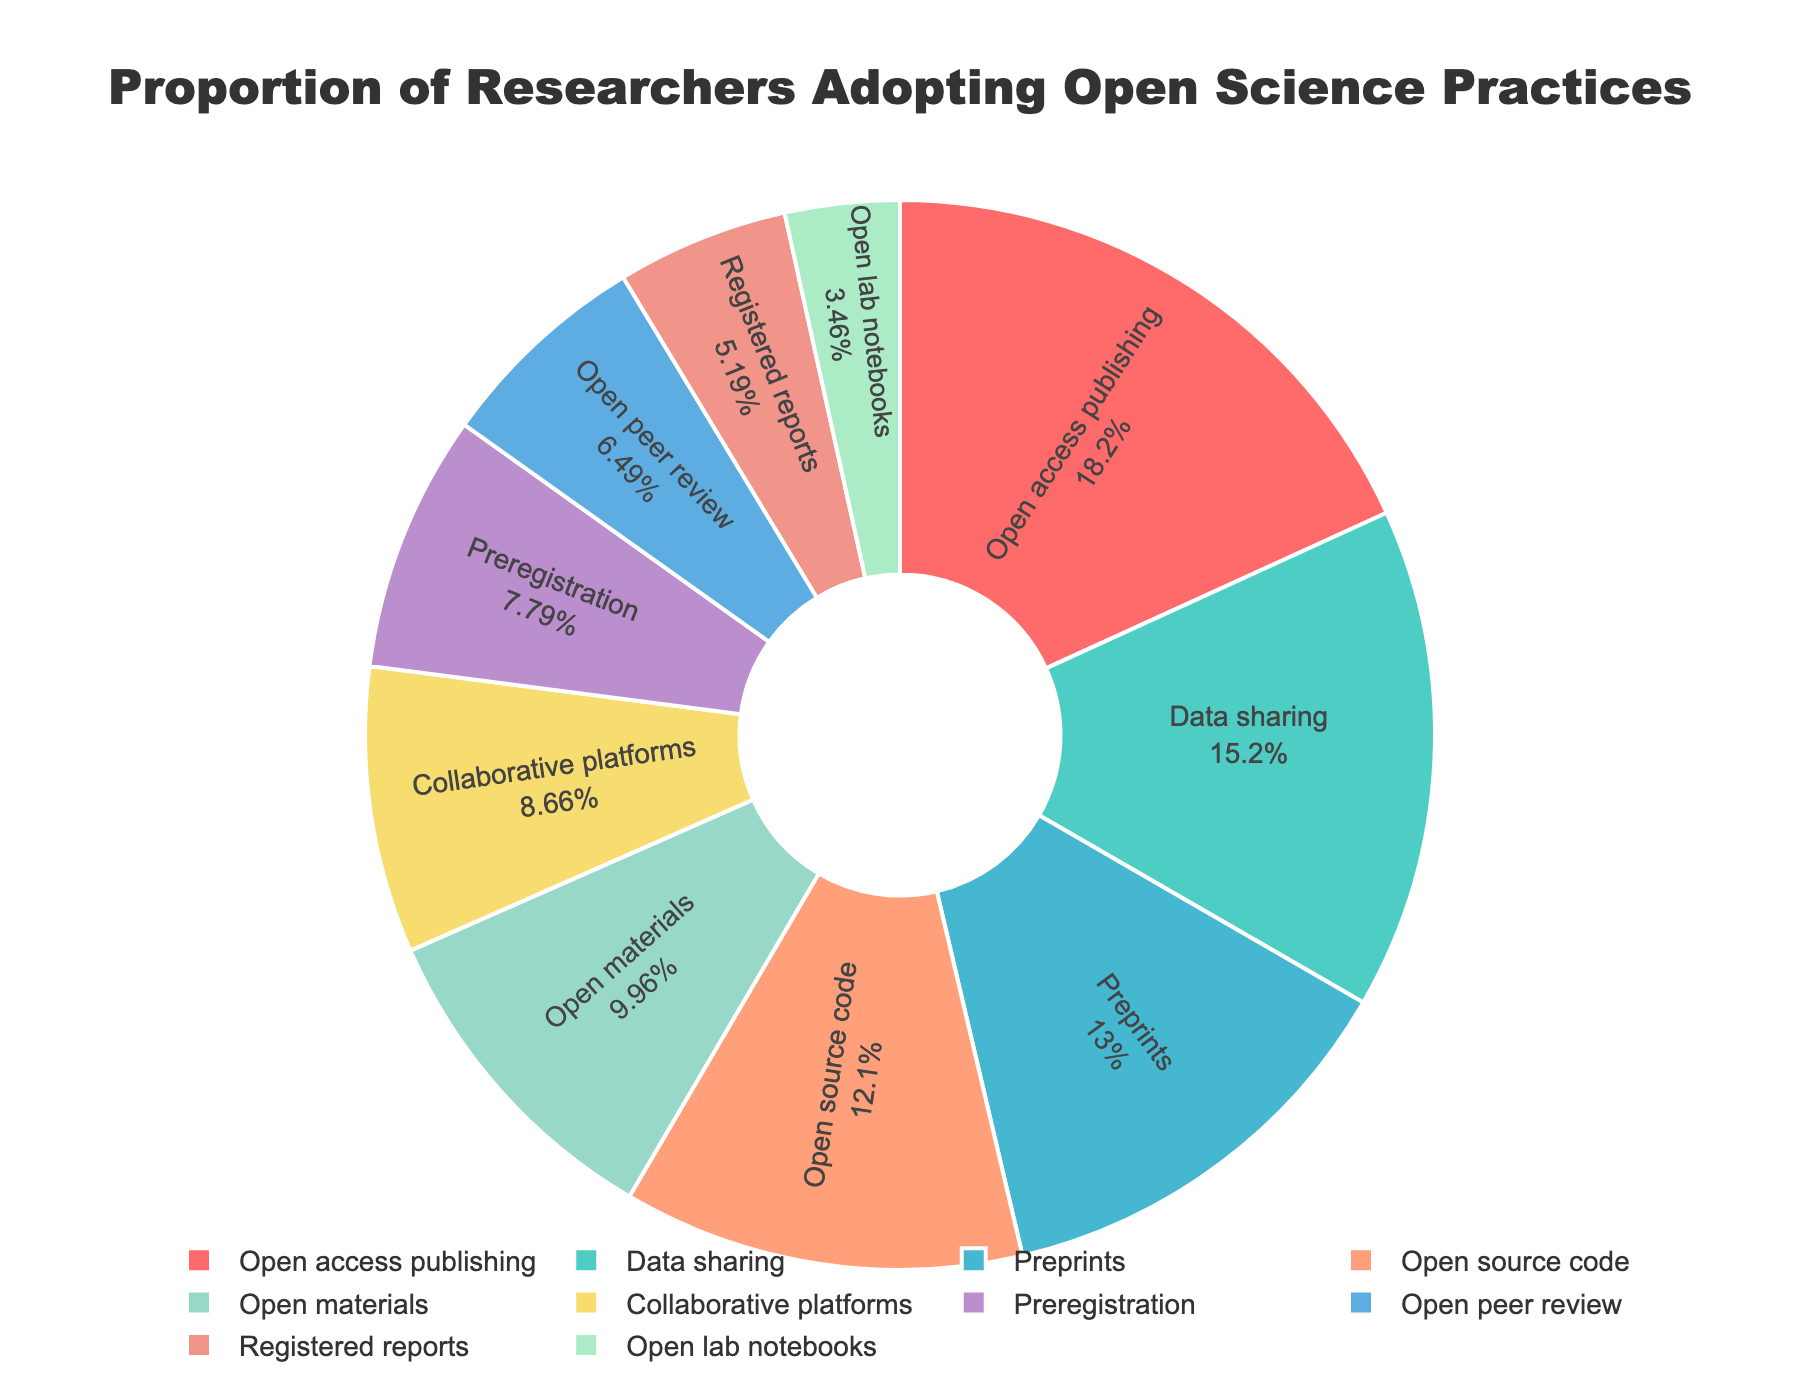Which open science practice has the highest adoption rate? By looking at the pie chart, we can see which slice is the largest. The practice with the highest adoption rate is represented by the largest slice.
Answer: Open access publishing What is the difference in the adoption rates between Data Sharing and Open Lab Notebooks? Data Sharing has an adoption rate of 35%, and Open Lab Notebooks has an adoption rate of 8%. Subtract the smaller percentage from the larger one: 35% - 8% = 27%.
Answer: 27% Which practices have an adoption rate higher than 25%? By examining the slices and their corresponding percentages, we see that the practices with adoption rates higher than 25% are Data Sharing, Open Access Publishing, Open Source Code, and Preprints. They have adoption rates of 35%, 42%, 28%, and 30%, respectively.
Answer: Data Sharing, Open Access Publishing, Open Source Code, Preprints What proportion of researchers use either Preregistration or Registered Reports? The adoption rates for Preregistration and Registered Reports are 18% and 12%, respectively. Add these percentages together: 18% + 12% = 30%.
Answer: 30% Among Collaborative Platforms, Open Peer Review, and Open Materials, which has the greatest adoption rate? By examining the sizes of the slices representing these practices, we see that Open Materials has an adoption rate of 23%, Collaborative Platforms have 20%, and Open Peer Review has 15%. Therefore, Open Materials has the highest adoption rate among them.
Answer: Open Materials Which slice is colored red, and what practice does it represent? By analyzing the visual attributes of the pie chart, the red slice can be identified. The red slice represents Data Sharing.
Answer: Data Sharing How much more popular is Preprints compared to Registered Reports? The adoption rate for Preprints is 30%, and for Registered Reports, it is 12%. Subtract the smaller percentage from the larger one: 30% - 12% = 18%.
Answer: 18% Which two practices combined make up roughly half of the overall adoption rate? By examining the percentages, we can see that Open Access Publishing (42%) and Data Sharing (35%) together sum up to 42% + 35% = 77%. No other combinations come closer to half.
Answer: None What is the average adoption rate of Open Materials, Open Peer Review, and Open Lab Notebooks? The adoption rates for Open Materials, Open Peer Review, and Open Lab Notebooks are 23%, 15%, and 8%, respectively. Adding these percentages: 23% + 15% + 8% = 46%. Dividing by the number of practices: 46% / 3 ≈ 15.3%.
Answer: 15.3% What's the sum of percentages for all practices with less than 20% adoption rate? Practices with less than 20% are Preregistration (18%), Registered Reports (12%), Open Peer Review (15%), Open Lab Notebooks (8%), and Collaborative Platforms (20% does not qualify). Adding these: 18% + 12% + 15% + 8% = 53%.
Answer: 53% 